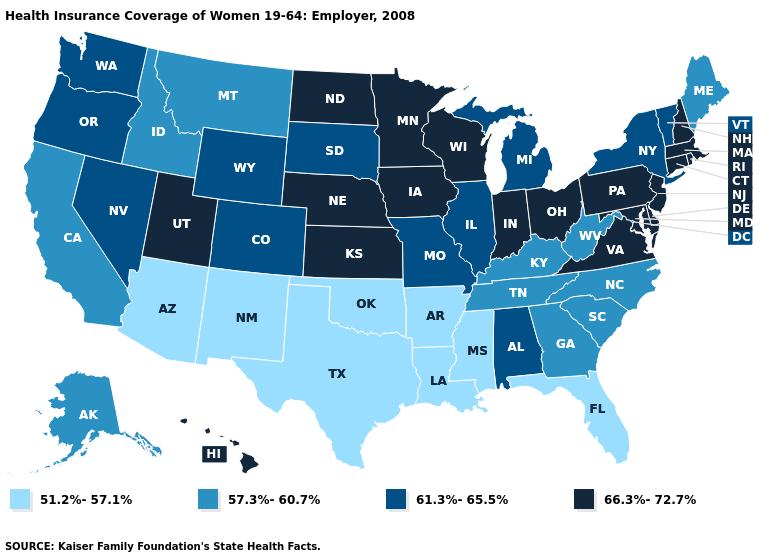Does Mississippi have the highest value in the South?
Keep it brief. No. Does Arizona have the highest value in the USA?
Write a very short answer. No. Does Virginia have the same value as Kansas?
Give a very brief answer. Yes. Among the states that border Indiana , does Illinois have the lowest value?
Answer briefly. No. What is the highest value in the Northeast ?
Be succinct. 66.3%-72.7%. Name the states that have a value in the range 61.3%-65.5%?
Concise answer only. Alabama, Colorado, Illinois, Michigan, Missouri, Nevada, New York, Oregon, South Dakota, Vermont, Washington, Wyoming. What is the value of Massachusetts?
Short answer required. 66.3%-72.7%. Does Iowa have the same value as Hawaii?
Be succinct. Yes. Which states have the highest value in the USA?
Give a very brief answer. Connecticut, Delaware, Hawaii, Indiana, Iowa, Kansas, Maryland, Massachusetts, Minnesota, Nebraska, New Hampshire, New Jersey, North Dakota, Ohio, Pennsylvania, Rhode Island, Utah, Virginia, Wisconsin. Which states hav the highest value in the West?
Keep it brief. Hawaii, Utah. What is the value of Maine?
Keep it brief. 57.3%-60.7%. How many symbols are there in the legend?
Give a very brief answer. 4. Among the states that border Nevada , which have the lowest value?
Short answer required. Arizona. What is the value of Kansas?
Answer briefly. 66.3%-72.7%. Does Arizona have the lowest value in the West?
Quick response, please. Yes. 